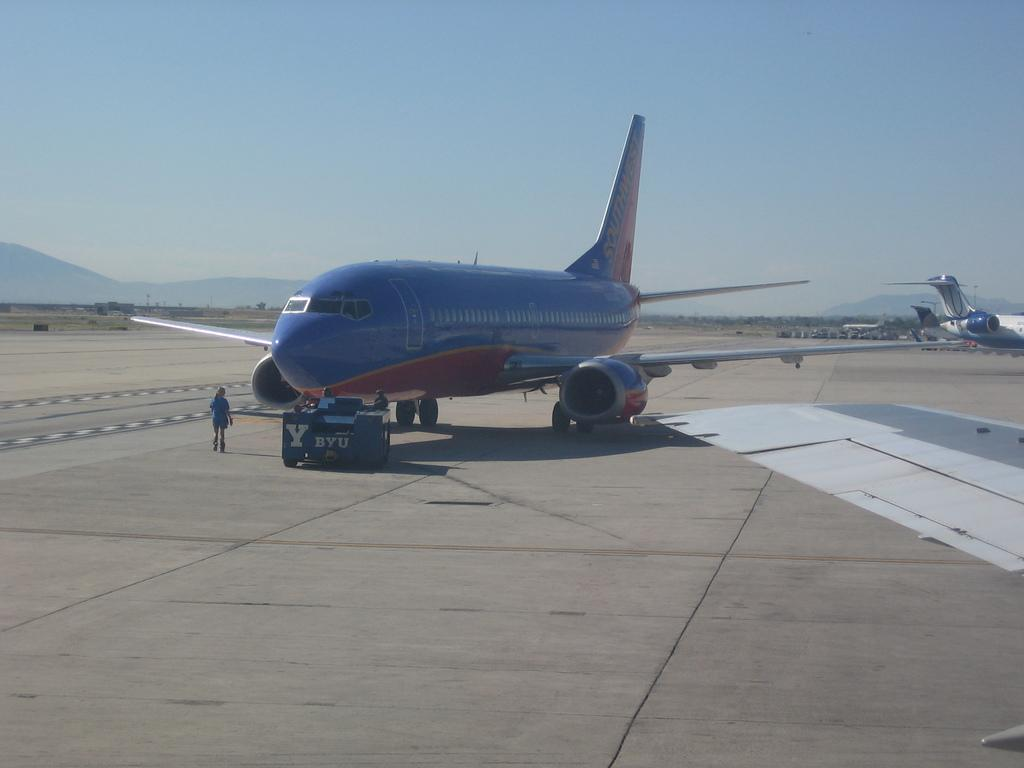<image>
Relay a brief, clear account of the picture shown. the shouthwest airlines plane is sitting away from the other planes in the area 